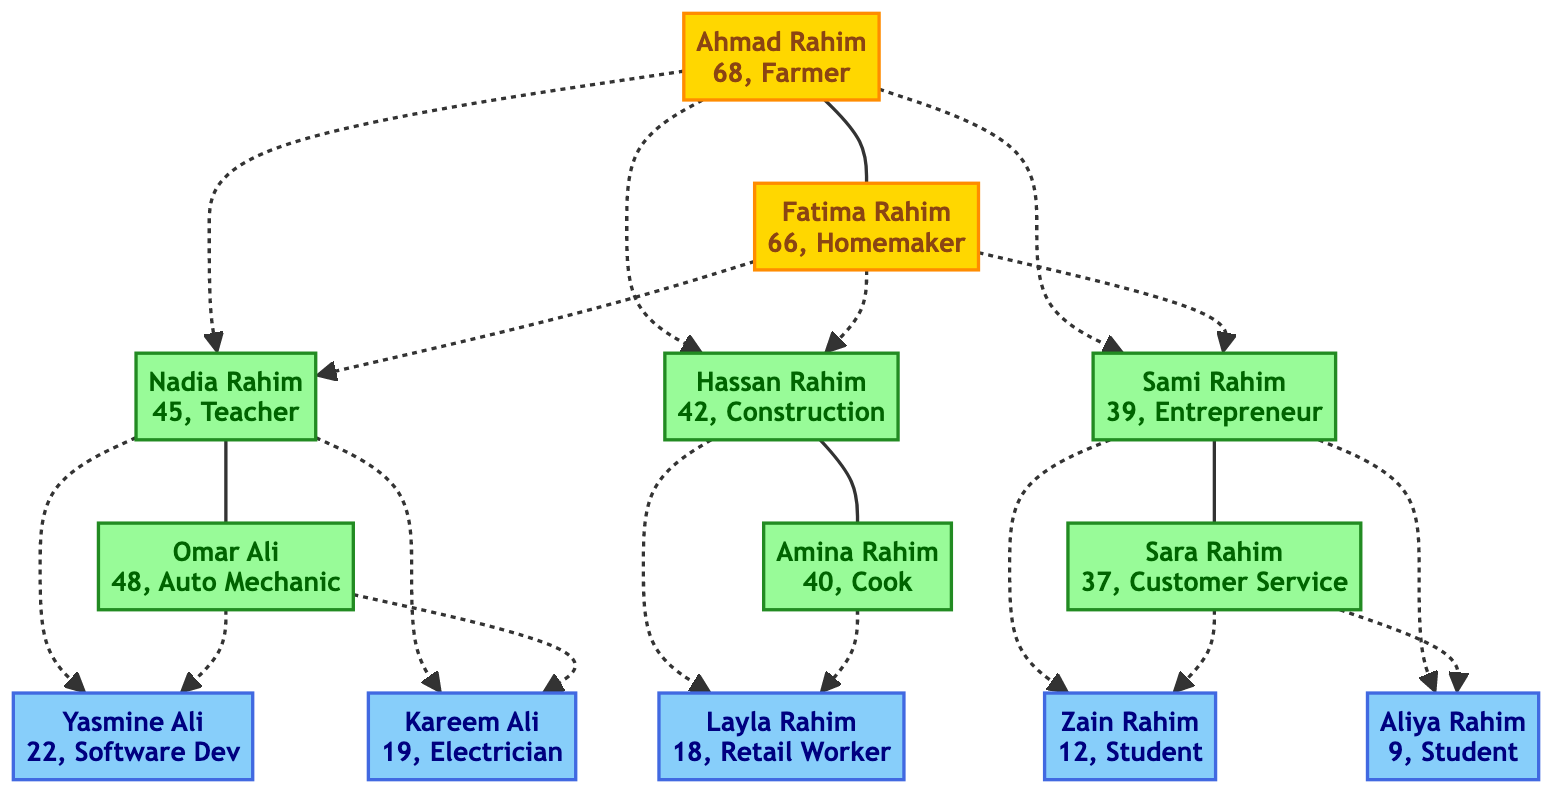What is the education level of Ahmad Rahim? The diagram indicates that Ahmad Rahim has "No Formal Education," which is outlined in his specific node in the tree.
Answer: No Formal Education How many children does Nadia Rahim have? By examining the connections in the diagram, it's clear that Nadia Rahim has two children, Yasmine Ali and Kareem Ali, as shown directly linked to her node.
Answer: 2 What is the career of Amina Rahim? The diagram presents Amina Rahim and states her career as "Restaurant Cook." This information is available in the node associated with her.
Answer: Restaurant Cook Which generation does Zain Rahim belong to? Looking at the structure of the family tree, Zain Rahim is listed as a child of Sami Rahim, which places him in the third generation of the family depicted in the tree.
Answer: Generation 3 What education did Sami Rahim achieve? Sami Rahim's node states "Associate Degree in Business Administration," clearly indicating his level of educational attainment.
Answer: Associate Degree in Business Administration Which career path is taken by the majority of Generation 2? By analyzing the careers in Generation 2, it's noted that among Nadia, Hassan, and Sami, two of them, Hassan Rahim and Amina Rahim, have no formal education and are in manual labor roles, whereas Nadia and Sami have educational and professional careers. Hence, two individuals work in less formal career paths compared to the others.
Answer: Manual Labor How are Yasmine Ali and Kareem Ali related to Omar Ali? The diagram shows that Yasmine and Kareem are listed as the children of Nadia Rahim and Omar Ali, indicating they are directly his children.
Answer: Children What is the age difference between Fatima Rahim and Hassan Rahim? Examining the ages of both, Fatima Rahim is 66 years old while Hassan Rahim is 42 years old, leading to an age difference of 24 years between them.
Answer: 24 years How many total family members are there in Generation 1? The family tree indicates that there are two individuals in Generation 1: Ahmad Rahim and Fatima Rahim. Therefore, the total count of family members in this generation is two.
Answer: 2 What field of study does Yasmine Ali specialize in? According to the information in the diagram, Yasmine Ali has obtained a degree in "Computer Science," which is clearly mentioned in her node.
Answer: Computer Science 